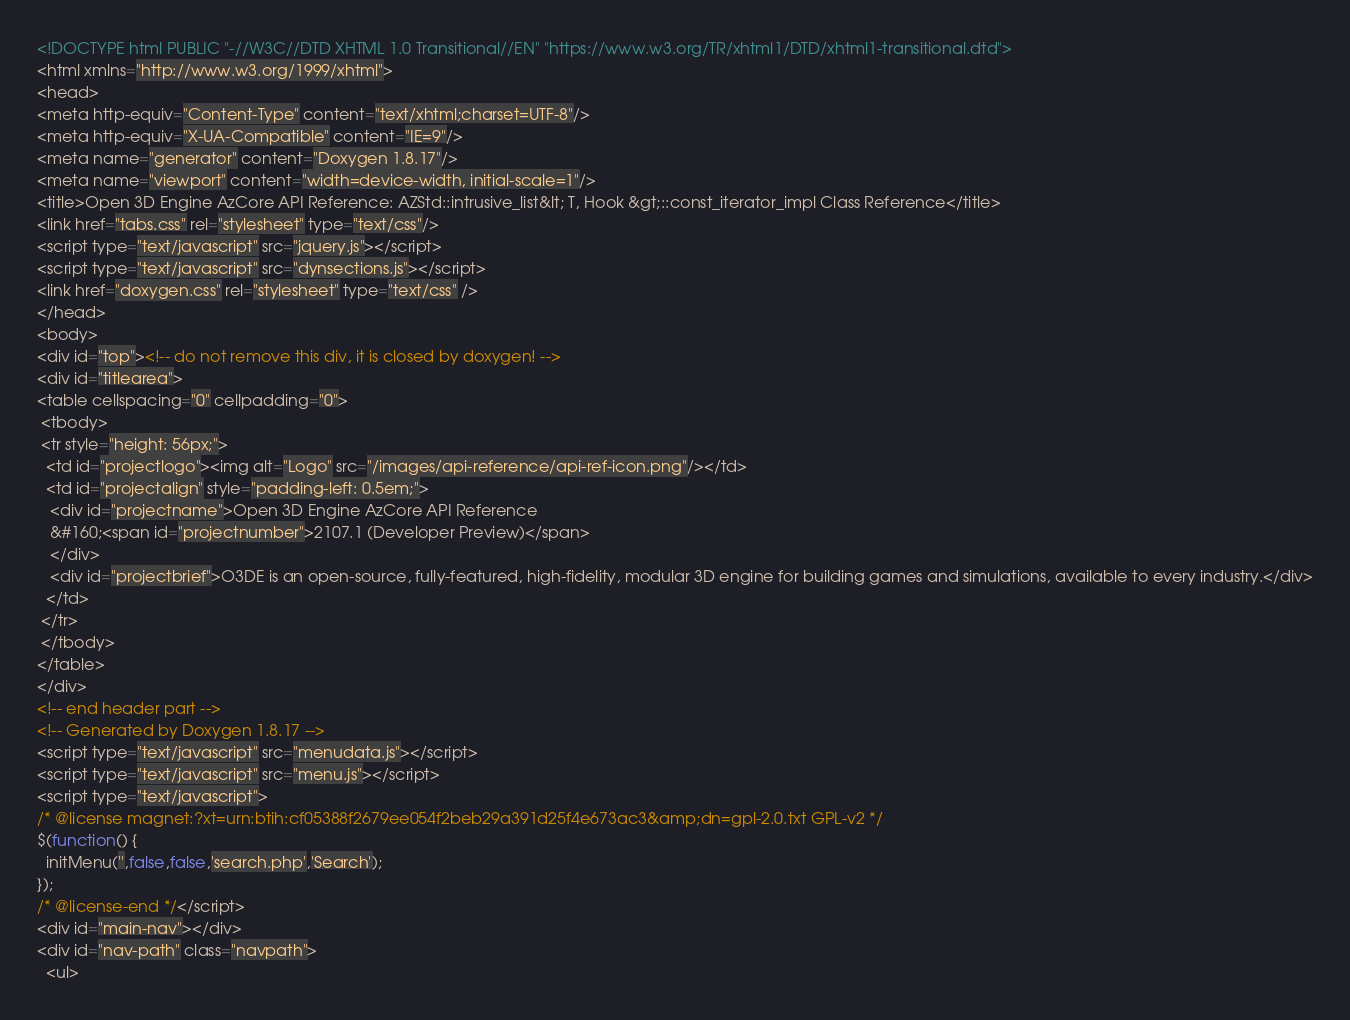Convert code to text. <code><loc_0><loc_0><loc_500><loc_500><_HTML_><!DOCTYPE html PUBLIC "-//W3C//DTD XHTML 1.0 Transitional//EN" "https://www.w3.org/TR/xhtml1/DTD/xhtml1-transitional.dtd">
<html xmlns="http://www.w3.org/1999/xhtml">
<head>
<meta http-equiv="Content-Type" content="text/xhtml;charset=UTF-8"/>
<meta http-equiv="X-UA-Compatible" content="IE=9"/>
<meta name="generator" content="Doxygen 1.8.17"/>
<meta name="viewport" content="width=device-width, initial-scale=1"/>
<title>Open 3D Engine AzCore API Reference: AZStd::intrusive_list&lt; T, Hook &gt;::const_iterator_impl Class Reference</title>
<link href="tabs.css" rel="stylesheet" type="text/css"/>
<script type="text/javascript" src="jquery.js"></script>
<script type="text/javascript" src="dynsections.js"></script>
<link href="doxygen.css" rel="stylesheet" type="text/css" />
</head>
<body>
<div id="top"><!-- do not remove this div, it is closed by doxygen! -->
<div id="titlearea">
<table cellspacing="0" cellpadding="0">
 <tbody>
 <tr style="height: 56px;">
  <td id="projectlogo"><img alt="Logo" src="/images/api-reference/api-ref-icon.png"/></td>
  <td id="projectalign" style="padding-left: 0.5em;">
   <div id="projectname">Open 3D Engine AzCore API Reference
   &#160;<span id="projectnumber">2107.1 (Developer Preview)</span>
   </div>
   <div id="projectbrief">O3DE is an open-source, fully-featured, high-fidelity, modular 3D engine for building games and simulations, available to every industry.</div>
  </td>
 </tr>
 </tbody>
</table>
</div>
<!-- end header part -->
<!-- Generated by Doxygen 1.8.17 -->
<script type="text/javascript" src="menudata.js"></script>
<script type="text/javascript" src="menu.js"></script>
<script type="text/javascript">
/* @license magnet:?xt=urn:btih:cf05388f2679ee054f2beb29a391d25f4e673ac3&amp;dn=gpl-2.0.txt GPL-v2 */
$(function() {
  initMenu('',false,false,'search.php','Search');
});
/* @license-end */</script>
<div id="main-nav"></div>
<div id="nav-path" class="navpath">
  <ul></code> 